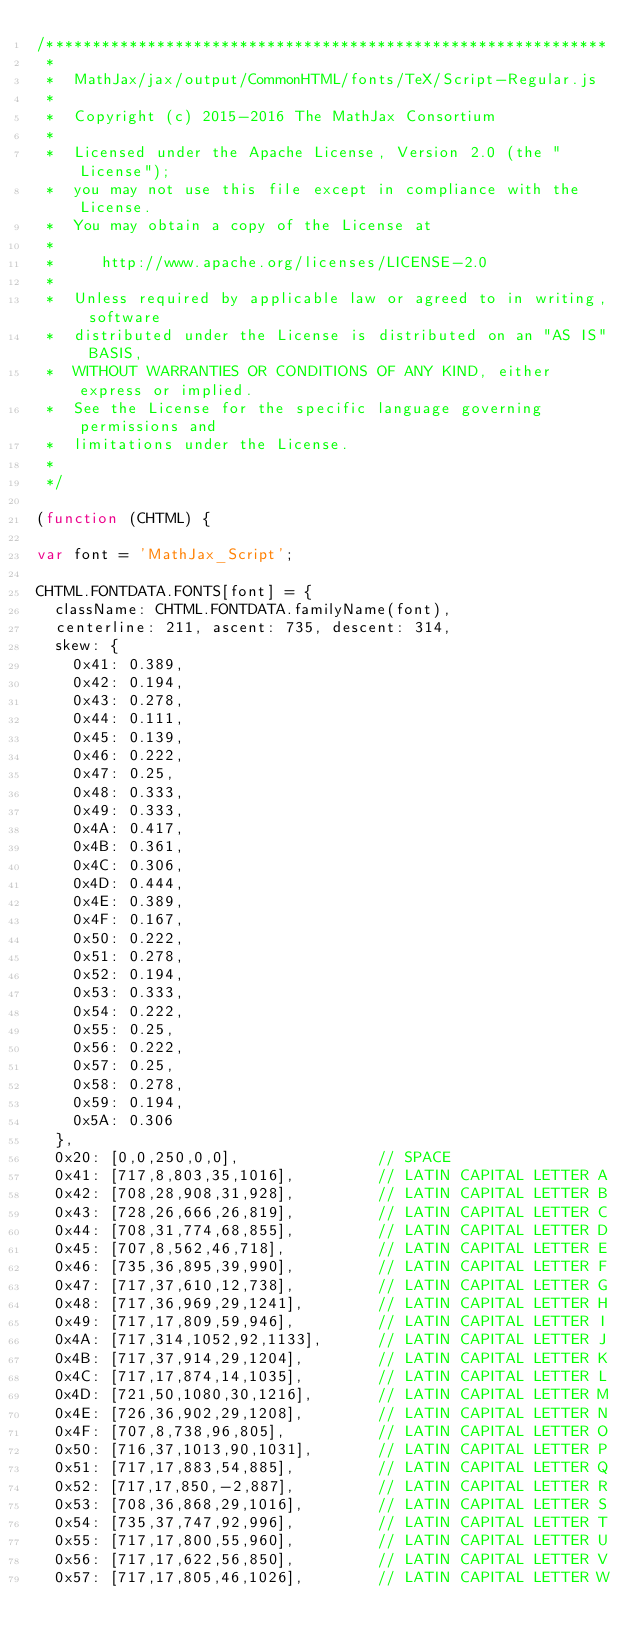<code> <loc_0><loc_0><loc_500><loc_500><_JavaScript_>/*************************************************************
 *
 *  MathJax/jax/output/CommonHTML/fonts/TeX/Script-Regular.js
 *
 *  Copyright (c) 2015-2016 The MathJax Consortium
 *
 *  Licensed under the Apache License, Version 2.0 (the "License");
 *  you may not use this file except in compliance with the License.
 *  You may obtain a copy of the License at
 *
 *     http://www.apache.org/licenses/LICENSE-2.0
 *
 *  Unless required by applicable law or agreed to in writing, software
 *  distributed under the License is distributed on an "AS IS" BASIS,
 *  WITHOUT WARRANTIES OR CONDITIONS OF ANY KIND, either express or implied.
 *  See the License for the specific language governing permissions and
 *  limitations under the License.
 *
 */

(function (CHTML) {

var font = 'MathJax_Script';

CHTML.FONTDATA.FONTS[font] = {
  className: CHTML.FONTDATA.familyName(font),
  centerline: 211, ascent: 735, descent: 314,
  skew: {
    0x41: 0.389,
    0x42: 0.194,
    0x43: 0.278,
    0x44: 0.111,
    0x45: 0.139,
    0x46: 0.222,
    0x47: 0.25,
    0x48: 0.333,
    0x49: 0.333,
    0x4A: 0.417,
    0x4B: 0.361,
    0x4C: 0.306,
    0x4D: 0.444,
    0x4E: 0.389,
    0x4F: 0.167,
    0x50: 0.222,
    0x51: 0.278,
    0x52: 0.194,
    0x53: 0.333,
    0x54: 0.222,
    0x55: 0.25,
    0x56: 0.222,
    0x57: 0.25,
    0x58: 0.278,
    0x59: 0.194,
    0x5A: 0.306
  },
  0x20: [0,0,250,0,0],               // SPACE
  0x41: [717,8,803,35,1016],         // LATIN CAPITAL LETTER A
  0x42: [708,28,908,31,928],         // LATIN CAPITAL LETTER B
  0x43: [728,26,666,26,819],         // LATIN CAPITAL LETTER C
  0x44: [708,31,774,68,855],         // LATIN CAPITAL LETTER D
  0x45: [707,8,562,46,718],          // LATIN CAPITAL LETTER E
  0x46: [735,36,895,39,990],         // LATIN CAPITAL LETTER F
  0x47: [717,37,610,12,738],         // LATIN CAPITAL LETTER G
  0x48: [717,36,969,29,1241],        // LATIN CAPITAL LETTER H
  0x49: [717,17,809,59,946],         // LATIN CAPITAL LETTER I
  0x4A: [717,314,1052,92,1133],      // LATIN CAPITAL LETTER J
  0x4B: [717,37,914,29,1204],        // LATIN CAPITAL LETTER K
  0x4C: [717,17,874,14,1035],        // LATIN CAPITAL LETTER L
  0x4D: [721,50,1080,30,1216],       // LATIN CAPITAL LETTER M
  0x4E: [726,36,902,29,1208],        // LATIN CAPITAL LETTER N
  0x4F: [707,8,738,96,805],          // LATIN CAPITAL LETTER O
  0x50: [716,37,1013,90,1031],       // LATIN CAPITAL LETTER P
  0x51: [717,17,883,54,885],         // LATIN CAPITAL LETTER Q
  0x52: [717,17,850,-2,887],         // LATIN CAPITAL LETTER R
  0x53: [708,36,868,29,1016],        // LATIN CAPITAL LETTER S
  0x54: [735,37,747,92,996],         // LATIN CAPITAL LETTER T
  0x55: [717,17,800,55,960],         // LATIN CAPITAL LETTER U
  0x56: [717,17,622,56,850],         // LATIN CAPITAL LETTER V
  0x57: [717,17,805,46,1026],        // LATIN CAPITAL LETTER W</code> 